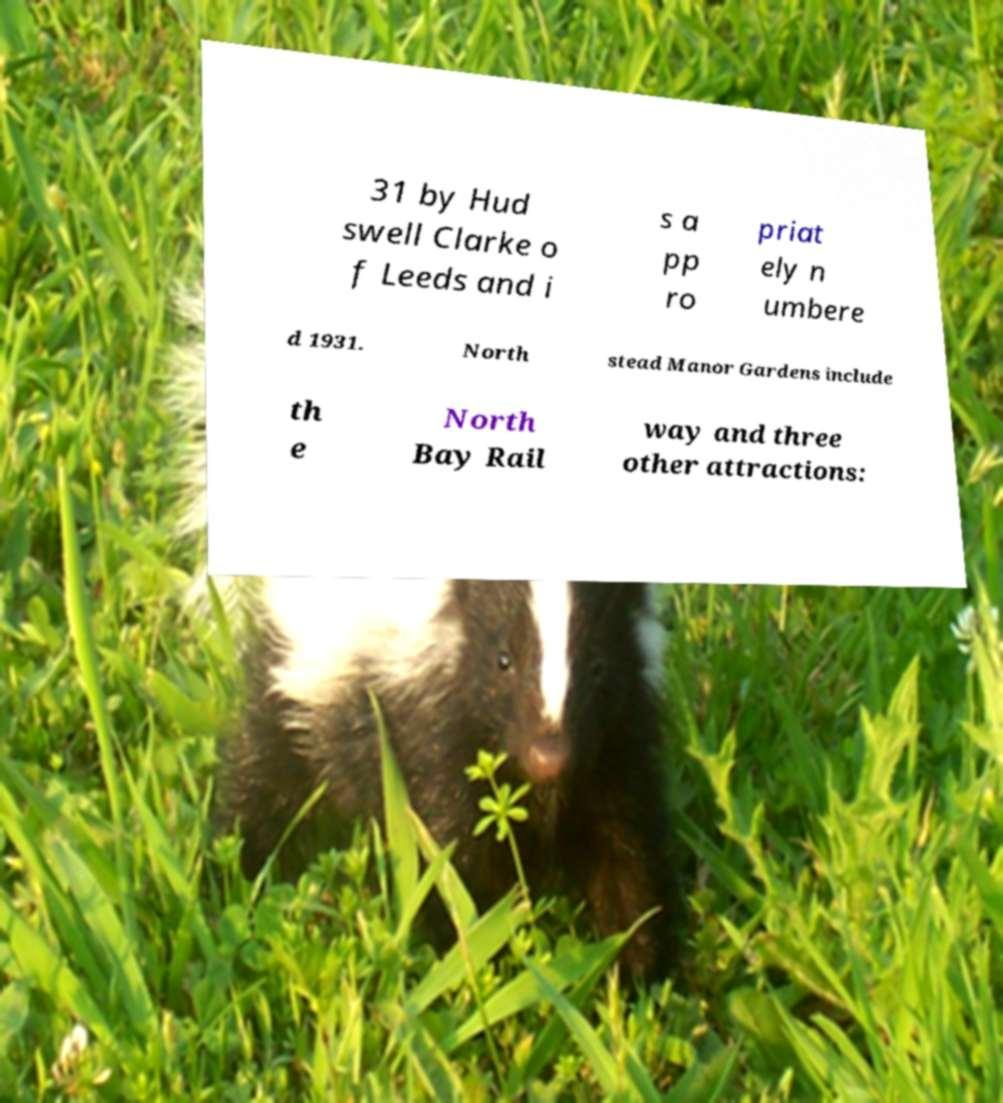There's text embedded in this image that I need extracted. Can you transcribe it verbatim? 31 by Hud swell Clarke o f Leeds and i s a pp ro priat ely n umbere d 1931. North stead Manor Gardens include th e North Bay Rail way and three other attractions: 